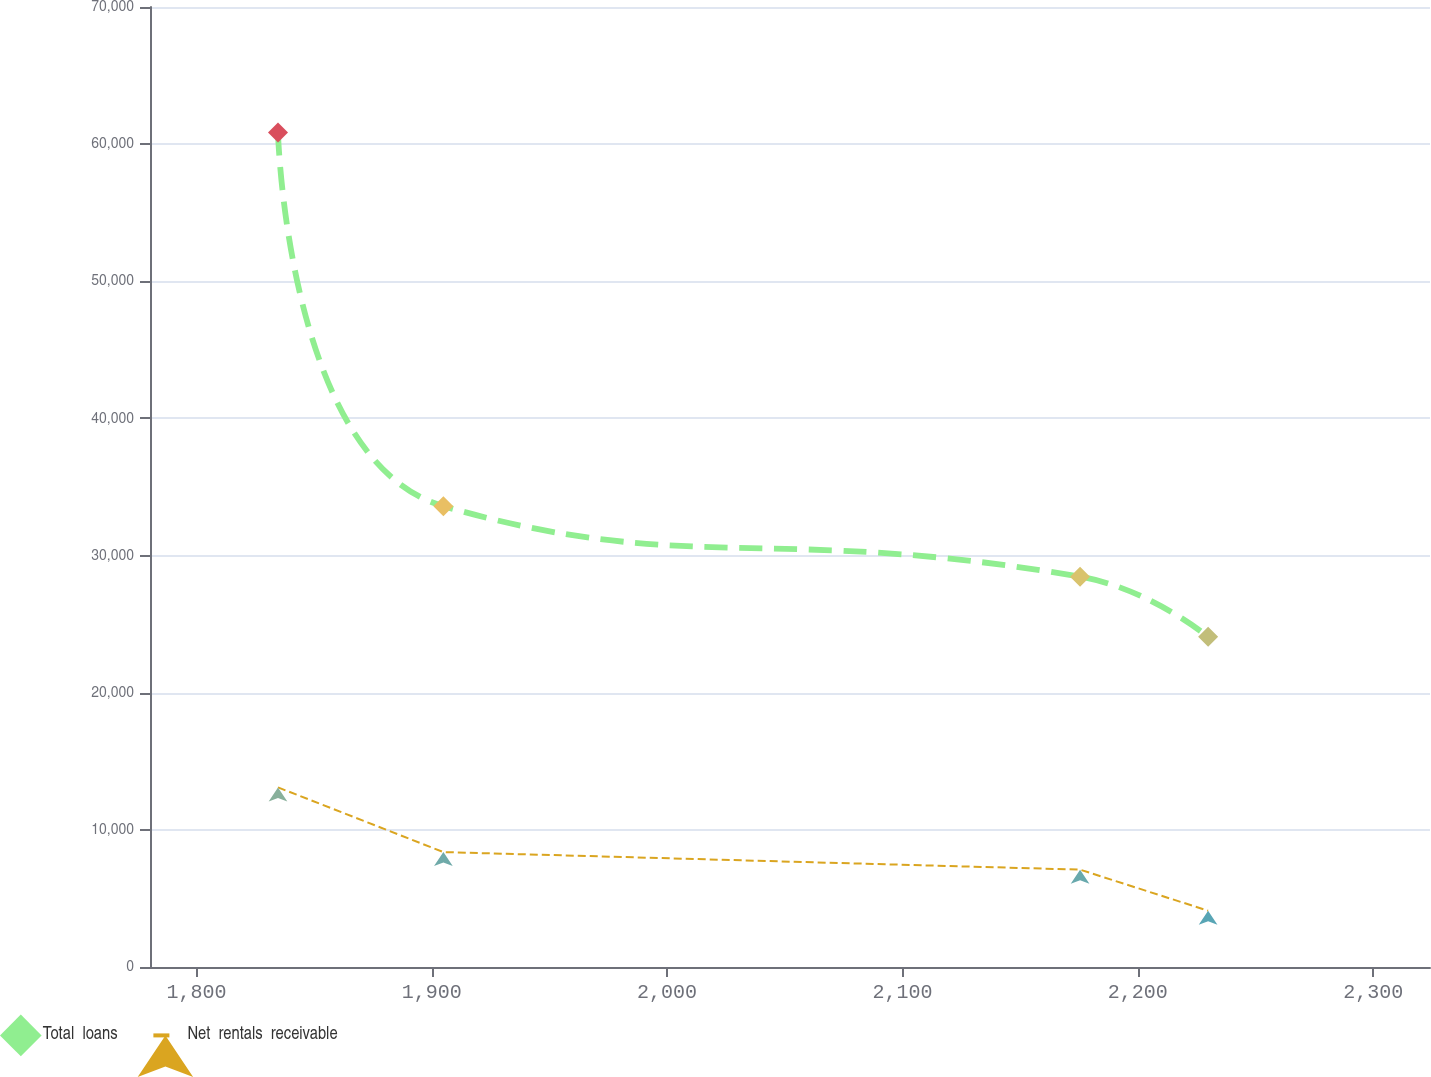<chart> <loc_0><loc_0><loc_500><loc_500><line_chart><ecel><fcel>Total  loans<fcel>Net  rentals  receivable<nl><fcel>1834.67<fcel>60857.6<fcel>13096.3<nl><fcel>1904.94<fcel>33604.6<fcel>8379.97<nl><fcel>2175.47<fcel>28463.5<fcel>7098.41<nl><fcel>2229.86<fcel>24077.7<fcel>4105.47<nl><fcel>2378.53<fcel>16998.8<fcel>2583.04<nl></chart> 